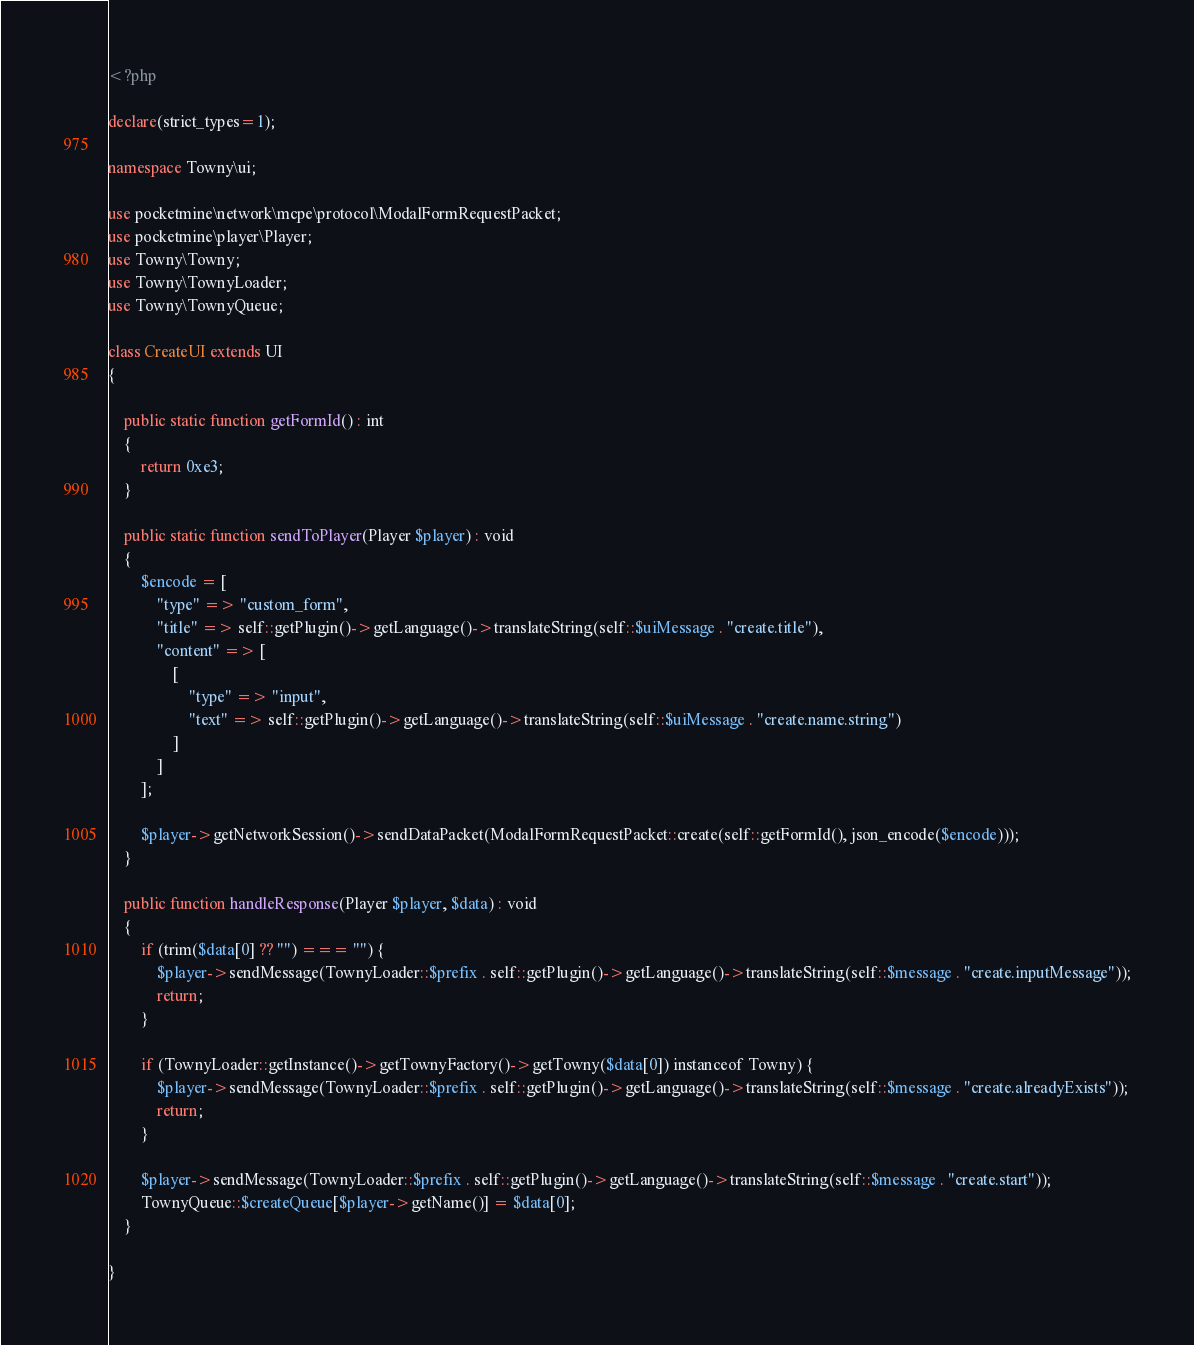Convert code to text. <code><loc_0><loc_0><loc_500><loc_500><_PHP_><?php

declare(strict_types=1);

namespace Towny\ui;

use pocketmine\network\mcpe\protocol\ModalFormRequestPacket;
use pocketmine\player\Player;
use Towny\Towny;
use Towny\TownyLoader;
use Towny\TownyQueue;

class CreateUI extends UI
{

    public static function getFormId() : int
    {
        return 0xe3;
    }

    public static function sendToPlayer(Player $player) : void
    {
        $encode = [
            "type" => "custom_form",
            "title" => self::getPlugin()->getLanguage()->translateString(self::$uiMessage . "create.title"),
            "content" => [
                [
                    "type" => "input",
                    "text" => self::getPlugin()->getLanguage()->translateString(self::$uiMessage . "create.name.string")
                ]
            ]
        ];

        $player->getNetworkSession()->sendDataPacket(ModalFormRequestPacket::create(self::getFormId(), json_encode($encode)));
    }

    public function handleResponse(Player $player, $data) : void
    {
        if (trim($data[0] ?? "") === "") {
            $player->sendMessage(TownyLoader::$prefix . self::getPlugin()->getLanguage()->translateString(self::$message . "create.inputMessage"));
            return;
        }

        if (TownyLoader::getInstance()->getTownyFactory()->getTowny($data[0]) instanceof Towny) {
            $player->sendMessage(TownyLoader::$prefix . self::getPlugin()->getLanguage()->translateString(self::$message . "create.alreadyExists"));
            return;
        }

        $player->sendMessage(TownyLoader::$prefix . self::getPlugin()->getLanguage()->translateString(self::$message . "create.start"));
        TownyQueue::$createQueue[$player->getName()] = $data[0];
    }

}
</code> 